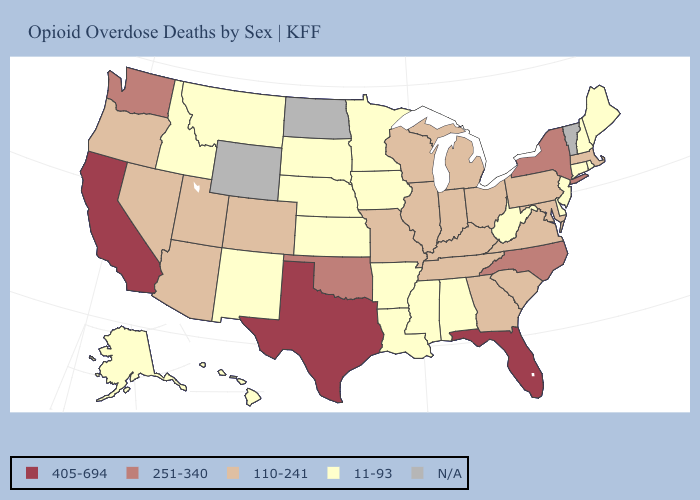What is the highest value in the USA?
Give a very brief answer. 405-694. Name the states that have a value in the range 11-93?
Concise answer only. Alabama, Alaska, Arkansas, Connecticut, Delaware, Hawaii, Idaho, Iowa, Kansas, Louisiana, Maine, Minnesota, Mississippi, Montana, Nebraska, New Hampshire, New Jersey, New Mexico, Rhode Island, South Dakota, West Virginia. What is the lowest value in the USA?
Keep it brief. 11-93. Name the states that have a value in the range 251-340?
Concise answer only. New York, North Carolina, Oklahoma, Washington. Among the states that border New York , which have the highest value?
Be succinct. Massachusetts, Pennsylvania. What is the highest value in the MidWest ?
Keep it brief. 110-241. Name the states that have a value in the range 251-340?
Write a very short answer. New York, North Carolina, Oklahoma, Washington. What is the value of Nebraska?
Write a very short answer. 11-93. Which states hav the highest value in the Northeast?
Answer briefly. New York. What is the value of Nevada?
Concise answer only. 110-241. Is the legend a continuous bar?
Keep it brief. No. Does the map have missing data?
Be succinct. Yes. Does Illinois have the lowest value in the USA?
Answer briefly. No. Does Alabama have the lowest value in the USA?
Keep it brief. Yes. Does the map have missing data?
Short answer required. Yes. 